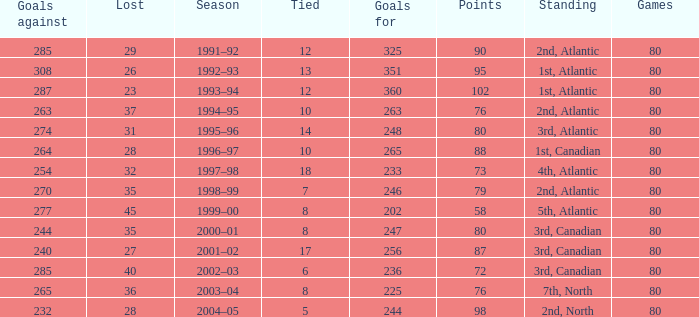How many goals against have 58 points? 277.0. 